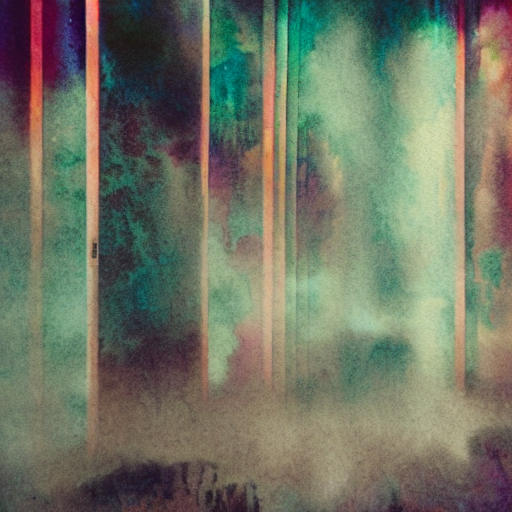What emotions might this image convey to a viewer? The use of muted, diffused colors and the soft intermingling of shapes may evoke a calm, dreamlike quality in the viewer. The abstract nature of the image leaves much to interpretation, allowing individuals to project their own sentiments. Some might perceive a sense of melancholy due to the subdued palette, while others might feel a sense of serenity. The image seems aimed at eliciting an introspective or contemplative emotional response. 